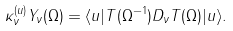Convert formula to latex. <formula><loc_0><loc_0><loc_500><loc_500>\kappa _ { \nu } ^ { ( u ) } Y _ { \nu } ( \Omega ) = \langle u | T ( \Omega ^ { - 1 } ) D _ { \nu } T ( \Omega ) | u \rangle .</formula> 